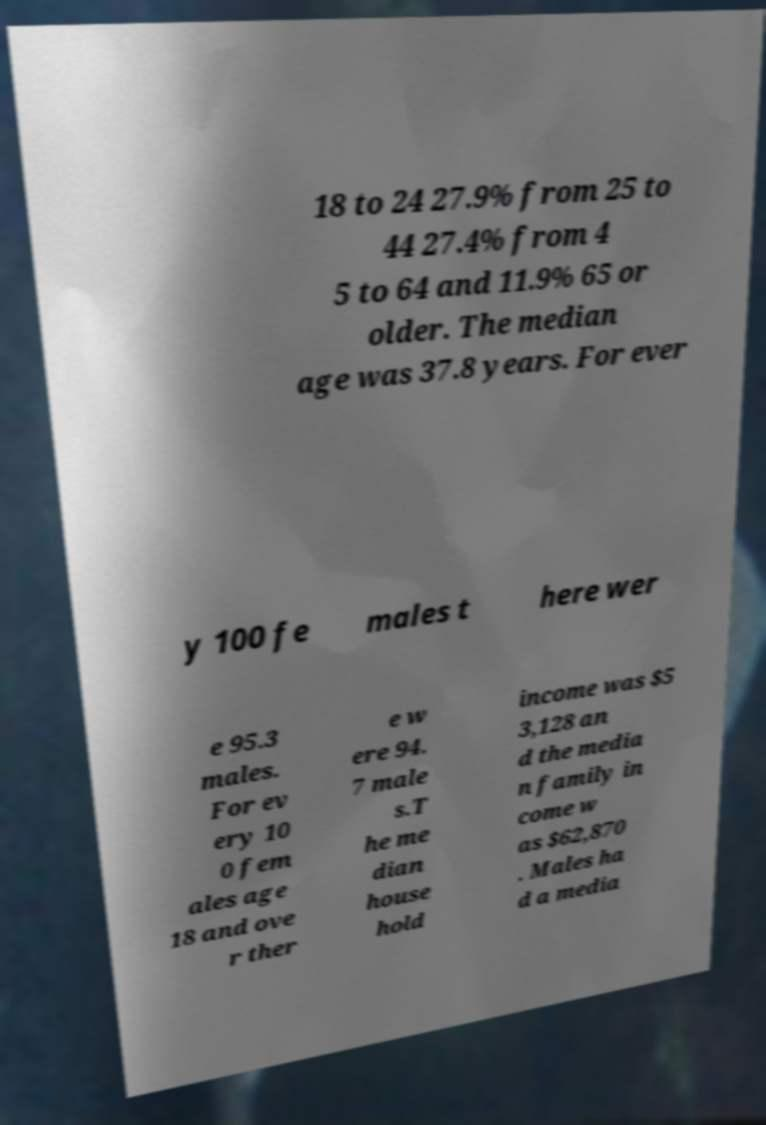There's text embedded in this image that I need extracted. Can you transcribe it verbatim? 18 to 24 27.9% from 25 to 44 27.4% from 4 5 to 64 and 11.9% 65 or older. The median age was 37.8 years. For ever y 100 fe males t here wer e 95.3 males. For ev ery 10 0 fem ales age 18 and ove r ther e w ere 94. 7 male s.T he me dian house hold income was $5 3,128 an d the media n family in come w as $62,870 . Males ha d a media 